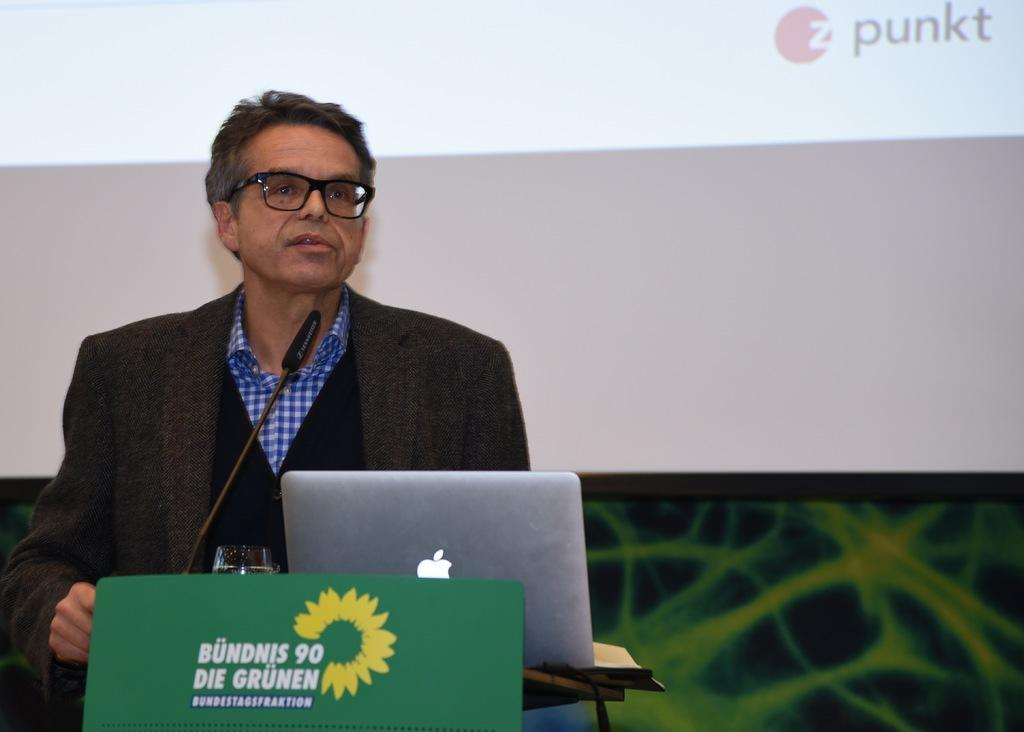What is the person doing in the image? There is a person standing at a desk in the image. What can be seen on the desk? There is a laptop, a tumbler, and a mic on the desk. What is visible in the background of the image? There is a screen and a wall in the background. What is the person's current desire in the image? There is no information about the person's desires in the image; it only shows them standing at a desk with various objects. What is the person talking about in the image? There is no indication of a conversation or any talking in the image; it only shows a person standing at a desk with various objects. 